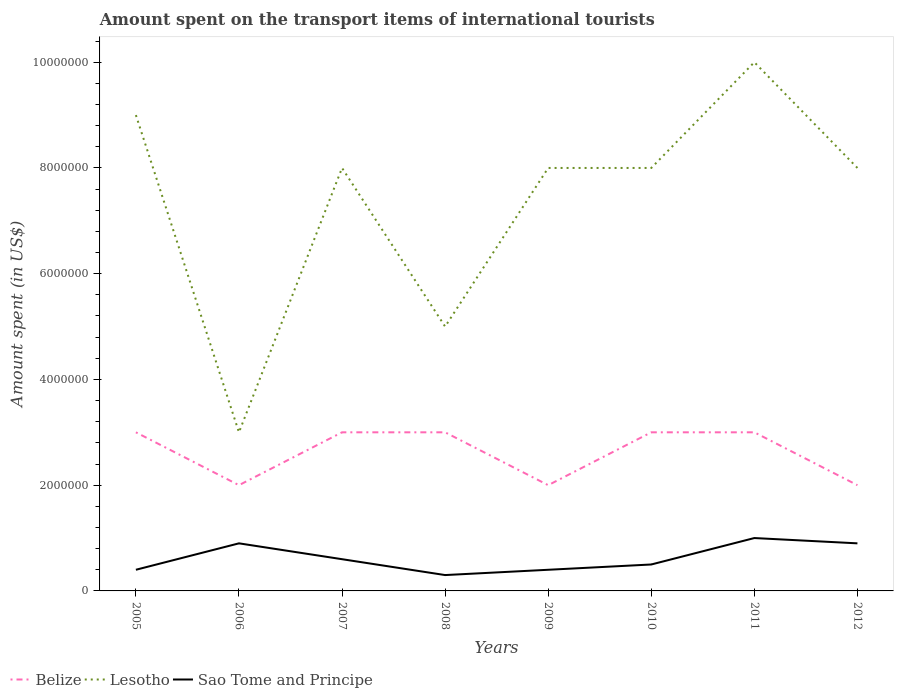Does the line corresponding to Belize intersect with the line corresponding to Lesotho?
Ensure brevity in your answer.  No. Across all years, what is the maximum amount spent on the transport items of international tourists in Lesotho?
Make the answer very short. 3.00e+06. What is the total amount spent on the transport items of international tourists in Lesotho in the graph?
Give a very brief answer. 1.00e+06. What is the difference between the highest and the second highest amount spent on the transport items of international tourists in Lesotho?
Your answer should be very brief. 7.00e+06. How many lines are there?
Offer a very short reply. 3. What is the difference between two consecutive major ticks on the Y-axis?
Make the answer very short. 2.00e+06. Are the values on the major ticks of Y-axis written in scientific E-notation?
Ensure brevity in your answer.  No. Does the graph contain any zero values?
Provide a short and direct response. No. How are the legend labels stacked?
Ensure brevity in your answer.  Horizontal. What is the title of the graph?
Provide a short and direct response. Amount spent on the transport items of international tourists. Does "Portugal" appear as one of the legend labels in the graph?
Ensure brevity in your answer.  No. What is the label or title of the X-axis?
Give a very brief answer. Years. What is the label or title of the Y-axis?
Provide a short and direct response. Amount spent (in US$). What is the Amount spent (in US$) in Lesotho in 2005?
Offer a very short reply. 9.00e+06. What is the Amount spent (in US$) of Sao Tome and Principe in 2005?
Ensure brevity in your answer.  4.00e+05. What is the Amount spent (in US$) in Lesotho in 2006?
Make the answer very short. 3.00e+06. What is the Amount spent (in US$) of Belize in 2007?
Give a very brief answer. 3.00e+06. What is the Amount spent (in US$) of Sao Tome and Principe in 2007?
Make the answer very short. 6.00e+05. What is the Amount spent (in US$) of Belize in 2008?
Give a very brief answer. 3.00e+06. What is the Amount spent (in US$) in Lesotho in 2008?
Your response must be concise. 5.00e+06. What is the Amount spent (in US$) in Sao Tome and Principe in 2008?
Keep it short and to the point. 3.00e+05. What is the Amount spent (in US$) in Lesotho in 2009?
Your response must be concise. 8.00e+06. What is the Amount spent (in US$) of Sao Tome and Principe in 2009?
Your answer should be compact. 4.00e+05. What is the Amount spent (in US$) in Sao Tome and Principe in 2010?
Keep it short and to the point. 5.00e+05. What is the Amount spent (in US$) in Belize in 2012?
Provide a short and direct response. 2.00e+06. What is the Amount spent (in US$) of Sao Tome and Principe in 2012?
Offer a very short reply. 9.00e+05. Across all years, what is the maximum Amount spent (in US$) of Sao Tome and Principe?
Ensure brevity in your answer.  1.00e+06. Across all years, what is the minimum Amount spent (in US$) of Belize?
Provide a short and direct response. 2.00e+06. What is the total Amount spent (in US$) in Belize in the graph?
Your response must be concise. 2.10e+07. What is the total Amount spent (in US$) in Lesotho in the graph?
Provide a succinct answer. 5.90e+07. What is the total Amount spent (in US$) in Sao Tome and Principe in the graph?
Provide a succinct answer. 5.00e+06. What is the difference between the Amount spent (in US$) in Lesotho in 2005 and that in 2006?
Make the answer very short. 6.00e+06. What is the difference between the Amount spent (in US$) of Sao Tome and Principe in 2005 and that in 2006?
Give a very brief answer. -5.00e+05. What is the difference between the Amount spent (in US$) of Belize in 2005 and that in 2007?
Give a very brief answer. 0. What is the difference between the Amount spent (in US$) of Sao Tome and Principe in 2005 and that in 2008?
Your answer should be very brief. 1.00e+05. What is the difference between the Amount spent (in US$) of Belize in 2005 and that in 2010?
Provide a short and direct response. 0. What is the difference between the Amount spent (in US$) of Belize in 2005 and that in 2011?
Give a very brief answer. 0. What is the difference between the Amount spent (in US$) in Sao Tome and Principe in 2005 and that in 2011?
Offer a terse response. -6.00e+05. What is the difference between the Amount spent (in US$) of Belize in 2005 and that in 2012?
Your response must be concise. 1.00e+06. What is the difference between the Amount spent (in US$) of Sao Tome and Principe in 2005 and that in 2012?
Your answer should be compact. -5.00e+05. What is the difference between the Amount spent (in US$) in Belize in 2006 and that in 2007?
Make the answer very short. -1.00e+06. What is the difference between the Amount spent (in US$) of Lesotho in 2006 and that in 2007?
Provide a succinct answer. -5.00e+06. What is the difference between the Amount spent (in US$) of Belize in 2006 and that in 2008?
Make the answer very short. -1.00e+06. What is the difference between the Amount spent (in US$) of Lesotho in 2006 and that in 2008?
Give a very brief answer. -2.00e+06. What is the difference between the Amount spent (in US$) of Belize in 2006 and that in 2009?
Ensure brevity in your answer.  0. What is the difference between the Amount spent (in US$) in Lesotho in 2006 and that in 2009?
Ensure brevity in your answer.  -5.00e+06. What is the difference between the Amount spent (in US$) of Lesotho in 2006 and that in 2010?
Give a very brief answer. -5.00e+06. What is the difference between the Amount spent (in US$) of Belize in 2006 and that in 2011?
Offer a very short reply. -1.00e+06. What is the difference between the Amount spent (in US$) of Lesotho in 2006 and that in 2011?
Offer a very short reply. -7.00e+06. What is the difference between the Amount spent (in US$) of Lesotho in 2006 and that in 2012?
Keep it short and to the point. -5.00e+06. What is the difference between the Amount spent (in US$) in Sao Tome and Principe in 2006 and that in 2012?
Ensure brevity in your answer.  0. What is the difference between the Amount spent (in US$) of Sao Tome and Principe in 2007 and that in 2008?
Give a very brief answer. 3.00e+05. What is the difference between the Amount spent (in US$) in Sao Tome and Principe in 2007 and that in 2010?
Your answer should be compact. 1.00e+05. What is the difference between the Amount spent (in US$) of Belize in 2007 and that in 2011?
Provide a short and direct response. 0. What is the difference between the Amount spent (in US$) in Lesotho in 2007 and that in 2011?
Give a very brief answer. -2.00e+06. What is the difference between the Amount spent (in US$) in Sao Tome and Principe in 2007 and that in 2011?
Provide a succinct answer. -4.00e+05. What is the difference between the Amount spent (in US$) of Belize in 2007 and that in 2012?
Offer a very short reply. 1.00e+06. What is the difference between the Amount spent (in US$) in Belize in 2008 and that in 2009?
Your answer should be compact. 1.00e+06. What is the difference between the Amount spent (in US$) of Sao Tome and Principe in 2008 and that in 2009?
Provide a short and direct response. -1.00e+05. What is the difference between the Amount spent (in US$) of Belize in 2008 and that in 2010?
Your answer should be very brief. 0. What is the difference between the Amount spent (in US$) in Lesotho in 2008 and that in 2010?
Your answer should be very brief. -3.00e+06. What is the difference between the Amount spent (in US$) in Belize in 2008 and that in 2011?
Your answer should be very brief. 0. What is the difference between the Amount spent (in US$) of Lesotho in 2008 and that in 2011?
Ensure brevity in your answer.  -5.00e+06. What is the difference between the Amount spent (in US$) in Sao Tome and Principe in 2008 and that in 2011?
Your response must be concise. -7.00e+05. What is the difference between the Amount spent (in US$) in Belize in 2008 and that in 2012?
Offer a very short reply. 1.00e+06. What is the difference between the Amount spent (in US$) of Lesotho in 2008 and that in 2012?
Your answer should be very brief. -3.00e+06. What is the difference between the Amount spent (in US$) in Sao Tome and Principe in 2008 and that in 2012?
Offer a terse response. -6.00e+05. What is the difference between the Amount spent (in US$) in Belize in 2009 and that in 2010?
Provide a short and direct response. -1.00e+06. What is the difference between the Amount spent (in US$) in Lesotho in 2009 and that in 2010?
Give a very brief answer. 0. What is the difference between the Amount spent (in US$) of Sao Tome and Principe in 2009 and that in 2010?
Your answer should be compact. -1.00e+05. What is the difference between the Amount spent (in US$) of Sao Tome and Principe in 2009 and that in 2011?
Offer a terse response. -6.00e+05. What is the difference between the Amount spent (in US$) of Belize in 2009 and that in 2012?
Make the answer very short. 0. What is the difference between the Amount spent (in US$) of Lesotho in 2009 and that in 2012?
Give a very brief answer. 0. What is the difference between the Amount spent (in US$) in Sao Tome and Principe in 2009 and that in 2012?
Keep it short and to the point. -5.00e+05. What is the difference between the Amount spent (in US$) of Sao Tome and Principe in 2010 and that in 2011?
Provide a short and direct response. -5.00e+05. What is the difference between the Amount spent (in US$) in Sao Tome and Principe in 2010 and that in 2012?
Offer a terse response. -4.00e+05. What is the difference between the Amount spent (in US$) in Belize in 2011 and that in 2012?
Your answer should be very brief. 1.00e+06. What is the difference between the Amount spent (in US$) of Sao Tome and Principe in 2011 and that in 2012?
Provide a short and direct response. 1.00e+05. What is the difference between the Amount spent (in US$) in Belize in 2005 and the Amount spent (in US$) in Sao Tome and Principe in 2006?
Make the answer very short. 2.10e+06. What is the difference between the Amount spent (in US$) of Lesotho in 2005 and the Amount spent (in US$) of Sao Tome and Principe in 2006?
Your answer should be compact. 8.10e+06. What is the difference between the Amount spent (in US$) in Belize in 2005 and the Amount spent (in US$) in Lesotho in 2007?
Your response must be concise. -5.00e+06. What is the difference between the Amount spent (in US$) in Belize in 2005 and the Amount spent (in US$) in Sao Tome and Principe in 2007?
Keep it short and to the point. 2.40e+06. What is the difference between the Amount spent (in US$) in Lesotho in 2005 and the Amount spent (in US$) in Sao Tome and Principe in 2007?
Offer a terse response. 8.40e+06. What is the difference between the Amount spent (in US$) of Belize in 2005 and the Amount spent (in US$) of Sao Tome and Principe in 2008?
Make the answer very short. 2.70e+06. What is the difference between the Amount spent (in US$) in Lesotho in 2005 and the Amount spent (in US$) in Sao Tome and Principe in 2008?
Give a very brief answer. 8.70e+06. What is the difference between the Amount spent (in US$) in Belize in 2005 and the Amount spent (in US$) in Lesotho in 2009?
Give a very brief answer. -5.00e+06. What is the difference between the Amount spent (in US$) in Belize in 2005 and the Amount spent (in US$) in Sao Tome and Principe in 2009?
Give a very brief answer. 2.60e+06. What is the difference between the Amount spent (in US$) of Lesotho in 2005 and the Amount spent (in US$) of Sao Tome and Principe in 2009?
Your answer should be compact. 8.60e+06. What is the difference between the Amount spent (in US$) in Belize in 2005 and the Amount spent (in US$) in Lesotho in 2010?
Provide a short and direct response. -5.00e+06. What is the difference between the Amount spent (in US$) of Belize in 2005 and the Amount spent (in US$) of Sao Tome and Principe in 2010?
Offer a terse response. 2.50e+06. What is the difference between the Amount spent (in US$) of Lesotho in 2005 and the Amount spent (in US$) of Sao Tome and Principe in 2010?
Give a very brief answer. 8.50e+06. What is the difference between the Amount spent (in US$) in Belize in 2005 and the Amount spent (in US$) in Lesotho in 2011?
Your answer should be very brief. -7.00e+06. What is the difference between the Amount spent (in US$) in Belize in 2005 and the Amount spent (in US$) in Sao Tome and Principe in 2011?
Keep it short and to the point. 2.00e+06. What is the difference between the Amount spent (in US$) of Lesotho in 2005 and the Amount spent (in US$) of Sao Tome and Principe in 2011?
Offer a terse response. 8.00e+06. What is the difference between the Amount spent (in US$) of Belize in 2005 and the Amount spent (in US$) of Lesotho in 2012?
Keep it short and to the point. -5.00e+06. What is the difference between the Amount spent (in US$) of Belize in 2005 and the Amount spent (in US$) of Sao Tome and Principe in 2012?
Provide a succinct answer. 2.10e+06. What is the difference between the Amount spent (in US$) of Lesotho in 2005 and the Amount spent (in US$) of Sao Tome and Principe in 2012?
Ensure brevity in your answer.  8.10e+06. What is the difference between the Amount spent (in US$) in Belize in 2006 and the Amount spent (in US$) in Lesotho in 2007?
Give a very brief answer. -6.00e+06. What is the difference between the Amount spent (in US$) in Belize in 2006 and the Amount spent (in US$) in Sao Tome and Principe in 2007?
Ensure brevity in your answer.  1.40e+06. What is the difference between the Amount spent (in US$) in Lesotho in 2006 and the Amount spent (in US$) in Sao Tome and Principe in 2007?
Give a very brief answer. 2.40e+06. What is the difference between the Amount spent (in US$) of Belize in 2006 and the Amount spent (in US$) of Sao Tome and Principe in 2008?
Give a very brief answer. 1.70e+06. What is the difference between the Amount spent (in US$) of Lesotho in 2006 and the Amount spent (in US$) of Sao Tome and Principe in 2008?
Your answer should be very brief. 2.70e+06. What is the difference between the Amount spent (in US$) of Belize in 2006 and the Amount spent (in US$) of Lesotho in 2009?
Your answer should be very brief. -6.00e+06. What is the difference between the Amount spent (in US$) of Belize in 2006 and the Amount spent (in US$) of Sao Tome and Principe in 2009?
Make the answer very short. 1.60e+06. What is the difference between the Amount spent (in US$) in Lesotho in 2006 and the Amount spent (in US$) in Sao Tome and Principe in 2009?
Ensure brevity in your answer.  2.60e+06. What is the difference between the Amount spent (in US$) of Belize in 2006 and the Amount spent (in US$) of Lesotho in 2010?
Provide a succinct answer. -6.00e+06. What is the difference between the Amount spent (in US$) in Belize in 2006 and the Amount spent (in US$) in Sao Tome and Principe in 2010?
Make the answer very short. 1.50e+06. What is the difference between the Amount spent (in US$) of Lesotho in 2006 and the Amount spent (in US$) of Sao Tome and Principe in 2010?
Provide a succinct answer. 2.50e+06. What is the difference between the Amount spent (in US$) in Belize in 2006 and the Amount spent (in US$) in Lesotho in 2011?
Provide a succinct answer. -8.00e+06. What is the difference between the Amount spent (in US$) of Belize in 2006 and the Amount spent (in US$) of Sao Tome and Principe in 2011?
Provide a short and direct response. 1.00e+06. What is the difference between the Amount spent (in US$) of Lesotho in 2006 and the Amount spent (in US$) of Sao Tome and Principe in 2011?
Offer a very short reply. 2.00e+06. What is the difference between the Amount spent (in US$) in Belize in 2006 and the Amount spent (in US$) in Lesotho in 2012?
Your answer should be compact. -6.00e+06. What is the difference between the Amount spent (in US$) of Belize in 2006 and the Amount spent (in US$) of Sao Tome and Principe in 2012?
Make the answer very short. 1.10e+06. What is the difference between the Amount spent (in US$) in Lesotho in 2006 and the Amount spent (in US$) in Sao Tome and Principe in 2012?
Your answer should be compact. 2.10e+06. What is the difference between the Amount spent (in US$) in Belize in 2007 and the Amount spent (in US$) in Lesotho in 2008?
Give a very brief answer. -2.00e+06. What is the difference between the Amount spent (in US$) in Belize in 2007 and the Amount spent (in US$) in Sao Tome and Principe in 2008?
Keep it short and to the point. 2.70e+06. What is the difference between the Amount spent (in US$) in Lesotho in 2007 and the Amount spent (in US$) in Sao Tome and Principe in 2008?
Give a very brief answer. 7.70e+06. What is the difference between the Amount spent (in US$) in Belize in 2007 and the Amount spent (in US$) in Lesotho in 2009?
Ensure brevity in your answer.  -5.00e+06. What is the difference between the Amount spent (in US$) in Belize in 2007 and the Amount spent (in US$) in Sao Tome and Principe in 2009?
Make the answer very short. 2.60e+06. What is the difference between the Amount spent (in US$) in Lesotho in 2007 and the Amount spent (in US$) in Sao Tome and Principe in 2009?
Provide a succinct answer. 7.60e+06. What is the difference between the Amount spent (in US$) in Belize in 2007 and the Amount spent (in US$) in Lesotho in 2010?
Provide a succinct answer. -5.00e+06. What is the difference between the Amount spent (in US$) in Belize in 2007 and the Amount spent (in US$) in Sao Tome and Principe in 2010?
Give a very brief answer. 2.50e+06. What is the difference between the Amount spent (in US$) in Lesotho in 2007 and the Amount spent (in US$) in Sao Tome and Principe in 2010?
Your answer should be compact. 7.50e+06. What is the difference between the Amount spent (in US$) of Belize in 2007 and the Amount spent (in US$) of Lesotho in 2011?
Offer a terse response. -7.00e+06. What is the difference between the Amount spent (in US$) in Belize in 2007 and the Amount spent (in US$) in Sao Tome and Principe in 2011?
Your answer should be compact. 2.00e+06. What is the difference between the Amount spent (in US$) of Belize in 2007 and the Amount spent (in US$) of Lesotho in 2012?
Provide a succinct answer. -5.00e+06. What is the difference between the Amount spent (in US$) in Belize in 2007 and the Amount spent (in US$) in Sao Tome and Principe in 2012?
Your response must be concise. 2.10e+06. What is the difference between the Amount spent (in US$) in Lesotho in 2007 and the Amount spent (in US$) in Sao Tome and Principe in 2012?
Offer a very short reply. 7.10e+06. What is the difference between the Amount spent (in US$) of Belize in 2008 and the Amount spent (in US$) of Lesotho in 2009?
Your answer should be very brief. -5.00e+06. What is the difference between the Amount spent (in US$) in Belize in 2008 and the Amount spent (in US$) in Sao Tome and Principe in 2009?
Make the answer very short. 2.60e+06. What is the difference between the Amount spent (in US$) in Lesotho in 2008 and the Amount spent (in US$) in Sao Tome and Principe in 2009?
Your answer should be compact. 4.60e+06. What is the difference between the Amount spent (in US$) in Belize in 2008 and the Amount spent (in US$) in Lesotho in 2010?
Keep it short and to the point. -5.00e+06. What is the difference between the Amount spent (in US$) in Belize in 2008 and the Amount spent (in US$) in Sao Tome and Principe in 2010?
Offer a very short reply. 2.50e+06. What is the difference between the Amount spent (in US$) of Lesotho in 2008 and the Amount spent (in US$) of Sao Tome and Principe in 2010?
Your response must be concise. 4.50e+06. What is the difference between the Amount spent (in US$) of Belize in 2008 and the Amount spent (in US$) of Lesotho in 2011?
Your answer should be compact. -7.00e+06. What is the difference between the Amount spent (in US$) of Belize in 2008 and the Amount spent (in US$) of Lesotho in 2012?
Your answer should be very brief. -5.00e+06. What is the difference between the Amount spent (in US$) in Belize in 2008 and the Amount spent (in US$) in Sao Tome and Principe in 2012?
Your answer should be compact. 2.10e+06. What is the difference between the Amount spent (in US$) of Lesotho in 2008 and the Amount spent (in US$) of Sao Tome and Principe in 2012?
Offer a terse response. 4.10e+06. What is the difference between the Amount spent (in US$) in Belize in 2009 and the Amount spent (in US$) in Lesotho in 2010?
Offer a very short reply. -6.00e+06. What is the difference between the Amount spent (in US$) in Belize in 2009 and the Amount spent (in US$) in Sao Tome and Principe in 2010?
Provide a succinct answer. 1.50e+06. What is the difference between the Amount spent (in US$) in Lesotho in 2009 and the Amount spent (in US$) in Sao Tome and Principe in 2010?
Offer a terse response. 7.50e+06. What is the difference between the Amount spent (in US$) in Belize in 2009 and the Amount spent (in US$) in Lesotho in 2011?
Offer a terse response. -8.00e+06. What is the difference between the Amount spent (in US$) in Lesotho in 2009 and the Amount spent (in US$) in Sao Tome and Principe in 2011?
Give a very brief answer. 7.00e+06. What is the difference between the Amount spent (in US$) of Belize in 2009 and the Amount spent (in US$) of Lesotho in 2012?
Ensure brevity in your answer.  -6.00e+06. What is the difference between the Amount spent (in US$) in Belize in 2009 and the Amount spent (in US$) in Sao Tome and Principe in 2012?
Your answer should be very brief. 1.10e+06. What is the difference between the Amount spent (in US$) of Lesotho in 2009 and the Amount spent (in US$) of Sao Tome and Principe in 2012?
Your response must be concise. 7.10e+06. What is the difference between the Amount spent (in US$) of Belize in 2010 and the Amount spent (in US$) of Lesotho in 2011?
Ensure brevity in your answer.  -7.00e+06. What is the difference between the Amount spent (in US$) of Belize in 2010 and the Amount spent (in US$) of Lesotho in 2012?
Offer a very short reply. -5.00e+06. What is the difference between the Amount spent (in US$) of Belize in 2010 and the Amount spent (in US$) of Sao Tome and Principe in 2012?
Give a very brief answer. 2.10e+06. What is the difference between the Amount spent (in US$) of Lesotho in 2010 and the Amount spent (in US$) of Sao Tome and Principe in 2012?
Offer a terse response. 7.10e+06. What is the difference between the Amount spent (in US$) in Belize in 2011 and the Amount spent (in US$) in Lesotho in 2012?
Your answer should be compact. -5.00e+06. What is the difference between the Amount spent (in US$) in Belize in 2011 and the Amount spent (in US$) in Sao Tome and Principe in 2012?
Make the answer very short. 2.10e+06. What is the difference between the Amount spent (in US$) in Lesotho in 2011 and the Amount spent (in US$) in Sao Tome and Principe in 2012?
Ensure brevity in your answer.  9.10e+06. What is the average Amount spent (in US$) in Belize per year?
Your answer should be very brief. 2.62e+06. What is the average Amount spent (in US$) of Lesotho per year?
Offer a terse response. 7.38e+06. What is the average Amount spent (in US$) in Sao Tome and Principe per year?
Make the answer very short. 6.25e+05. In the year 2005, what is the difference between the Amount spent (in US$) in Belize and Amount spent (in US$) in Lesotho?
Your answer should be very brief. -6.00e+06. In the year 2005, what is the difference between the Amount spent (in US$) in Belize and Amount spent (in US$) in Sao Tome and Principe?
Provide a short and direct response. 2.60e+06. In the year 2005, what is the difference between the Amount spent (in US$) of Lesotho and Amount spent (in US$) of Sao Tome and Principe?
Give a very brief answer. 8.60e+06. In the year 2006, what is the difference between the Amount spent (in US$) of Belize and Amount spent (in US$) of Lesotho?
Offer a very short reply. -1.00e+06. In the year 2006, what is the difference between the Amount spent (in US$) of Belize and Amount spent (in US$) of Sao Tome and Principe?
Your response must be concise. 1.10e+06. In the year 2006, what is the difference between the Amount spent (in US$) in Lesotho and Amount spent (in US$) in Sao Tome and Principe?
Your answer should be very brief. 2.10e+06. In the year 2007, what is the difference between the Amount spent (in US$) in Belize and Amount spent (in US$) in Lesotho?
Provide a succinct answer. -5.00e+06. In the year 2007, what is the difference between the Amount spent (in US$) of Belize and Amount spent (in US$) of Sao Tome and Principe?
Give a very brief answer. 2.40e+06. In the year 2007, what is the difference between the Amount spent (in US$) in Lesotho and Amount spent (in US$) in Sao Tome and Principe?
Your answer should be very brief. 7.40e+06. In the year 2008, what is the difference between the Amount spent (in US$) in Belize and Amount spent (in US$) in Sao Tome and Principe?
Provide a short and direct response. 2.70e+06. In the year 2008, what is the difference between the Amount spent (in US$) in Lesotho and Amount spent (in US$) in Sao Tome and Principe?
Ensure brevity in your answer.  4.70e+06. In the year 2009, what is the difference between the Amount spent (in US$) of Belize and Amount spent (in US$) of Lesotho?
Offer a terse response. -6.00e+06. In the year 2009, what is the difference between the Amount spent (in US$) in Belize and Amount spent (in US$) in Sao Tome and Principe?
Make the answer very short. 1.60e+06. In the year 2009, what is the difference between the Amount spent (in US$) in Lesotho and Amount spent (in US$) in Sao Tome and Principe?
Your response must be concise. 7.60e+06. In the year 2010, what is the difference between the Amount spent (in US$) in Belize and Amount spent (in US$) in Lesotho?
Your answer should be very brief. -5.00e+06. In the year 2010, what is the difference between the Amount spent (in US$) in Belize and Amount spent (in US$) in Sao Tome and Principe?
Offer a terse response. 2.50e+06. In the year 2010, what is the difference between the Amount spent (in US$) of Lesotho and Amount spent (in US$) of Sao Tome and Principe?
Offer a terse response. 7.50e+06. In the year 2011, what is the difference between the Amount spent (in US$) in Belize and Amount spent (in US$) in Lesotho?
Keep it short and to the point. -7.00e+06. In the year 2011, what is the difference between the Amount spent (in US$) in Lesotho and Amount spent (in US$) in Sao Tome and Principe?
Your answer should be very brief. 9.00e+06. In the year 2012, what is the difference between the Amount spent (in US$) in Belize and Amount spent (in US$) in Lesotho?
Make the answer very short. -6.00e+06. In the year 2012, what is the difference between the Amount spent (in US$) in Belize and Amount spent (in US$) in Sao Tome and Principe?
Offer a terse response. 1.10e+06. In the year 2012, what is the difference between the Amount spent (in US$) of Lesotho and Amount spent (in US$) of Sao Tome and Principe?
Ensure brevity in your answer.  7.10e+06. What is the ratio of the Amount spent (in US$) in Belize in 2005 to that in 2006?
Your answer should be compact. 1.5. What is the ratio of the Amount spent (in US$) in Sao Tome and Principe in 2005 to that in 2006?
Offer a very short reply. 0.44. What is the ratio of the Amount spent (in US$) of Lesotho in 2005 to that in 2007?
Offer a terse response. 1.12. What is the ratio of the Amount spent (in US$) of Sao Tome and Principe in 2005 to that in 2007?
Offer a terse response. 0.67. What is the ratio of the Amount spent (in US$) in Lesotho in 2005 to that in 2008?
Your response must be concise. 1.8. What is the ratio of the Amount spent (in US$) of Lesotho in 2005 to that in 2009?
Offer a terse response. 1.12. What is the ratio of the Amount spent (in US$) in Sao Tome and Principe in 2005 to that in 2010?
Provide a succinct answer. 0.8. What is the ratio of the Amount spent (in US$) in Lesotho in 2005 to that in 2011?
Your answer should be compact. 0.9. What is the ratio of the Amount spent (in US$) in Sao Tome and Principe in 2005 to that in 2012?
Your answer should be very brief. 0.44. What is the ratio of the Amount spent (in US$) of Lesotho in 2006 to that in 2007?
Offer a very short reply. 0.38. What is the ratio of the Amount spent (in US$) of Sao Tome and Principe in 2006 to that in 2008?
Your response must be concise. 3. What is the ratio of the Amount spent (in US$) in Lesotho in 2006 to that in 2009?
Your answer should be compact. 0.38. What is the ratio of the Amount spent (in US$) in Sao Tome and Principe in 2006 to that in 2009?
Offer a very short reply. 2.25. What is the ratio of the Amount spent (in US$) in Belize in 2006 to that in 2010?
Your response must be concise. 0.67. What is the ratio of the Amount spent (in US$) in Sao Tome and Principe in 2006 to that in 2010?
Give a very brief answer. 1.8. What is the ratio of the Amount spent (in US$) in Lesotho in 2006 to that in 2011?
Your answer should be very brief. 0.3. What is the ratio of the Amount spent (in US$) in Belize in 2006 to that in 2012?
Give a very brief answer. 1. What is the ratio of the Amount spent (in US$) in Lesotho in 2006 to that in 2012?
Ensure brevity in your answer.  0.38. What is the ratio of the Amount spent (in US$) of Sao Tome and Principe in 2006 to that in 2012?
Keep it short and to the point. 1. What is the ratio of the Amount spent (in US$) of Lesotho in 2007 to that in 2008?
Your answer should be compact. 1.6. What is the ratio of the Amount spent (in US$) of Sao Tome and Principe in 2007 to that in 2008?
Offer a very short reply. 2. What is the ratio of the Amount spent (in US$) in Lesotho in 2007 to that in 2009?
Your response must be concise. 1. What is the ratio of the Amount spent (in US$) of Belize in 2007 to that in 2010?
Make the answer very short. 1. What is the ratio of the Amount spent (in US$) in Sao Tome and Principe in 2007 to that in 2010?
Keep it short and to the point. 1.2. What is the ratio of the Amount spent (in US$) of Belize in 2007 to that in 2011?
Provide a short and direct response. 1. What is the ratio of the Amount spent (in US$) in Belize in 2007 to that in 2012?
Provide a short and direct response. 1.5. What is the ratio of the Amount spent (in US$) of Sao Tome and Principe in 2007 to that in 2012?
Offer a very short reply. 0.67. What is the ratio of the Amount spent (in US$) of Belize in 2008 to that in 2009?
Your answer should be compact. 1.5. What is the ratio of the Amount spent (in US$) of Belize in 2008 to that in 2010?
Your answer should be compact. 1. What is the ratio of the Amount spent (in US$) in Lesotho in 2008 to that in 2010?
Give a very brief answer. 0.62. What is the ratio of the Amount spent (in US$) in Sao Tome and Principe in 2008 to that in 2010?
Your response must be concise. 0.6. What is the ratio of the Amount spent (in US$) in Belize in 2008 to that in 2011?
Your answer should be very brief. 1. What is the ratio of the Amount spent (in US$) of Belize in 2009 to that in 2010?
Make the answer very short. 0.67. What is the ratio of the Amount spent (in US$) in Lesotho in 2009 to that in 2010?
Your response must be concise. 1. What is the ratio of the Amount spent (in US$) of Sao Tome and Principe in 2009 to that in 2010?
Your response must be concise. 0.8. What is the ratio of the Amount spent (in US$) in Sao Tome and Principe in 2009 to that in 2011?
Provide a succinct answer. 0.4. What is the ratio of the Amount spent (in US$) in Sao Tome and Principe in 2009 to that in 2012?
Keep it short and to the point. 0.44. What is the ratio of the Amount spent (in US$) of Sao Tome and Principe in 2010 to that in 2011?
Your answer should be compact. 0.5. What is the ratio of the Amount spent (in US$) of Sao Tome and Principe in 2010 to that in 2012?
Provide a short and direct response. 0.56. What is the ratio of the Amount spent (in US$) in Belize in 2011 to that in 2012?
Provide a succinct answer. 1.5. What is the difference between the highest and the second highest Amount spent (in US$) in Belize?
Your response must be concise. 0. What is the difference between the highest and the second highest Amount spent (in US$) of Lesotho?
Offer a terse response. 1.00e+06. What is the difference between the highest and the lowest Amount spent (in US$) in Belize?
Your answer should be compact. 1.00e+06. What is the difference between the highest and the lowest Amount spent (in US$) of Sao Tome and Principe?
Provide a short and direct response. 7.00e+05. 